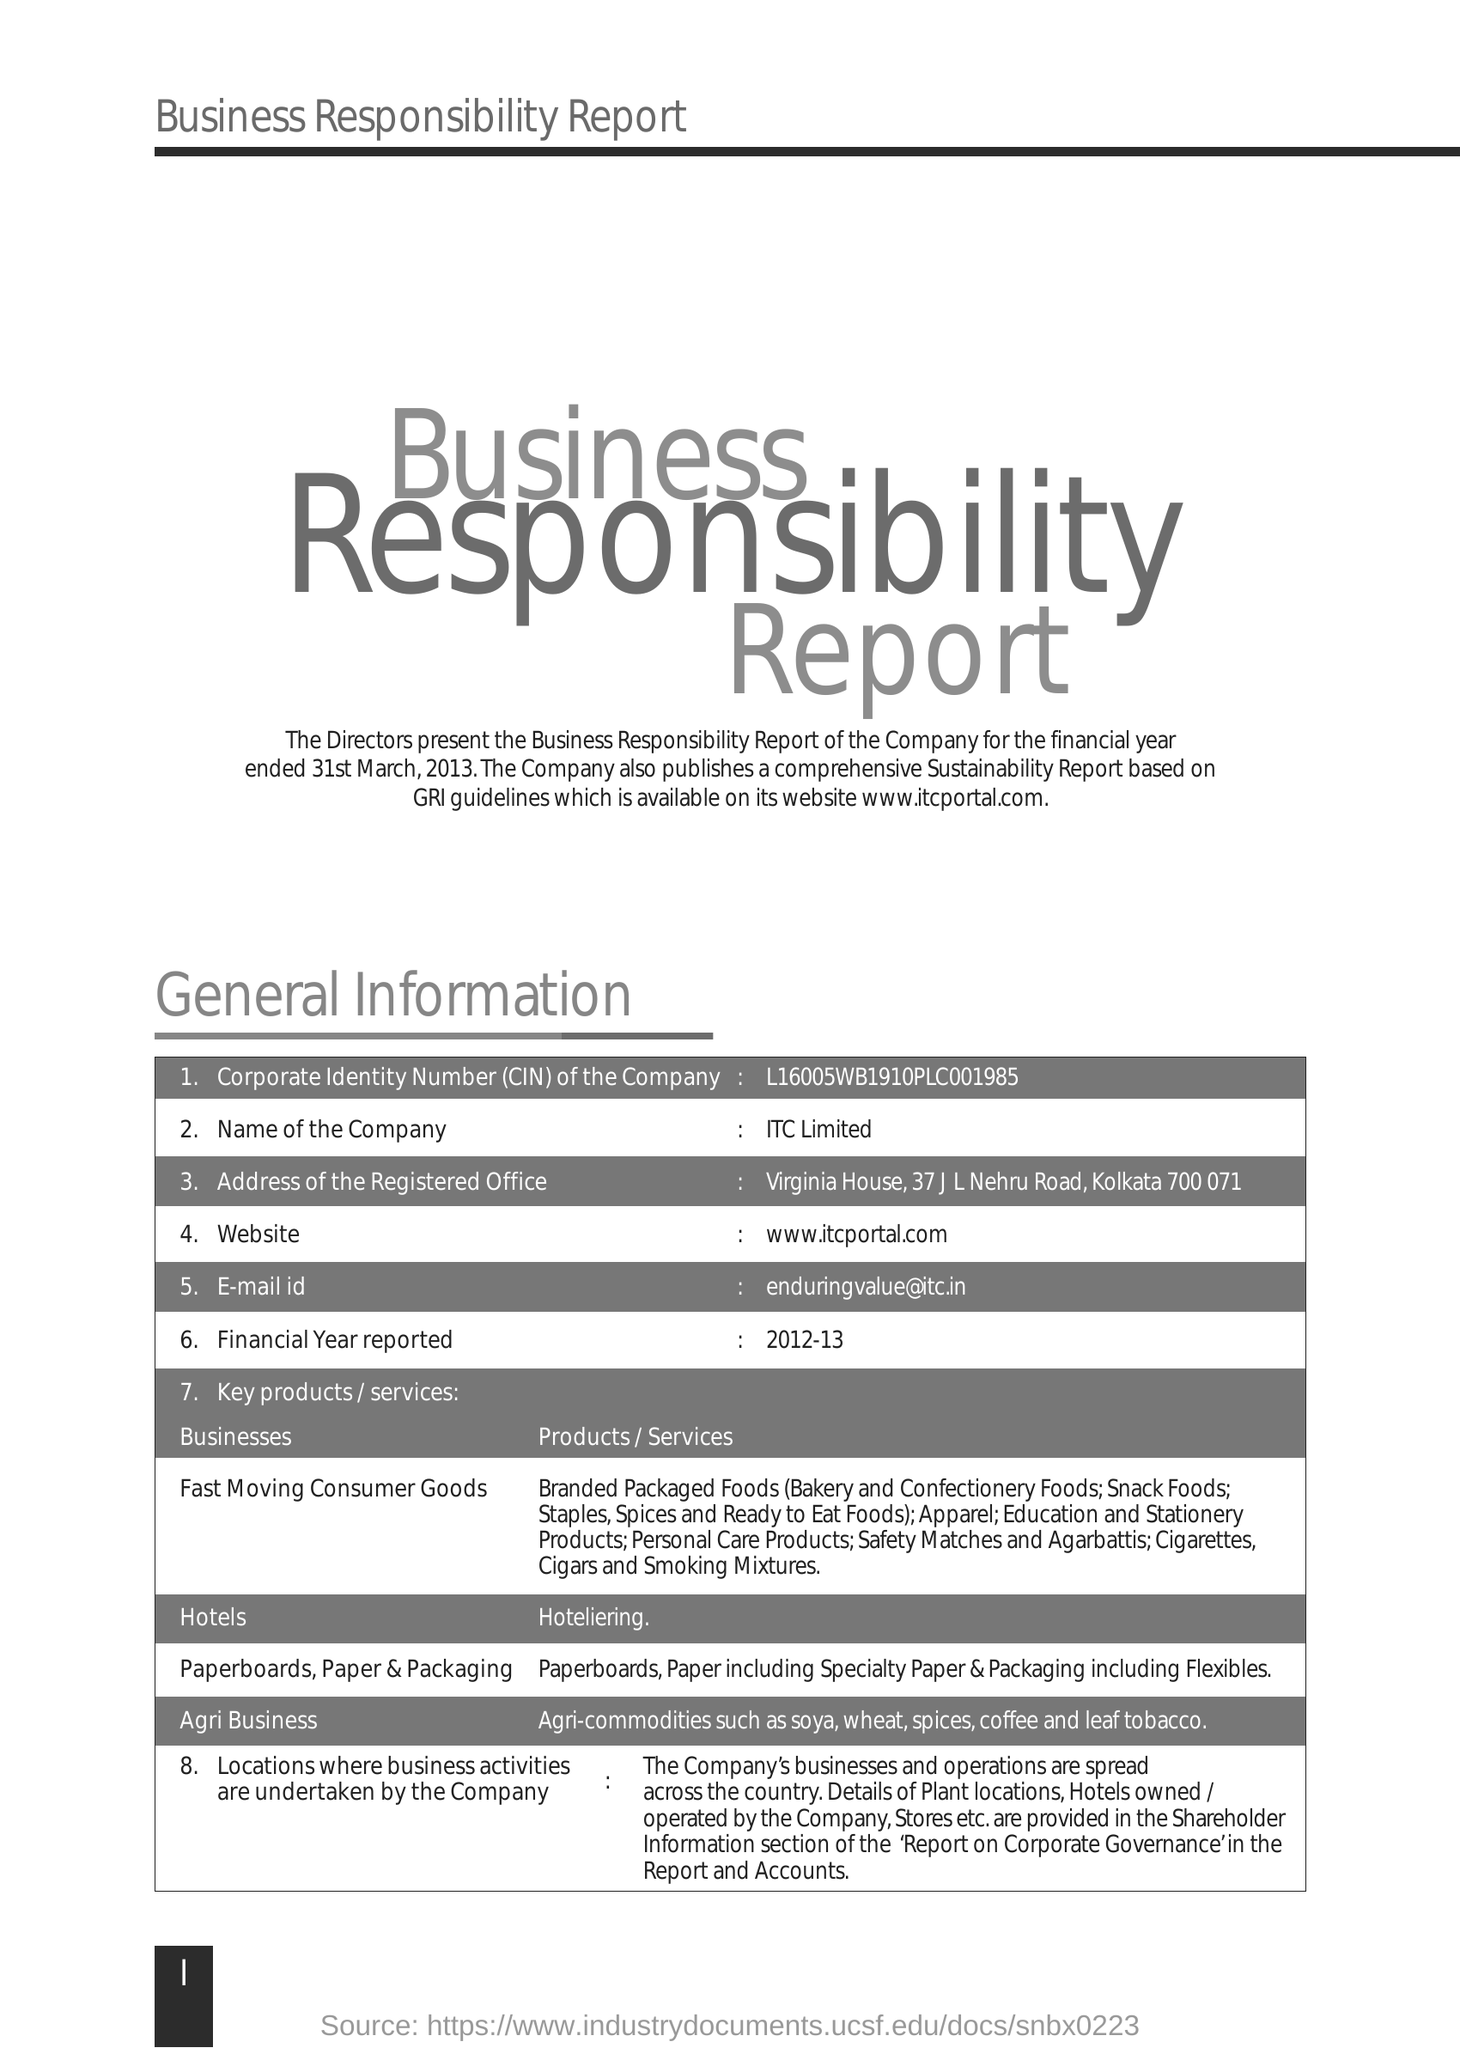What is the Corporate Identity Number of the Company
Offer a very short reply. L16005WB1910PlC001985. What is the full form of CIN  mention in form
Keep it short and to the point. Corporate Identity Number. What is the name of company
Your answer should be compact. ITC Limited. 